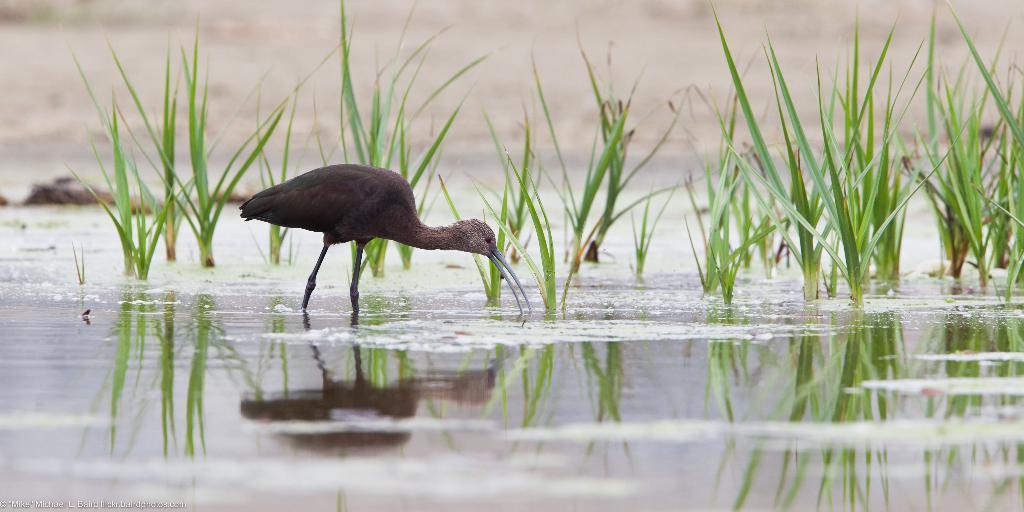How would you summarize this image in a sentence or two? In this image, we can see an animal and there are some green plants, we can see water. 